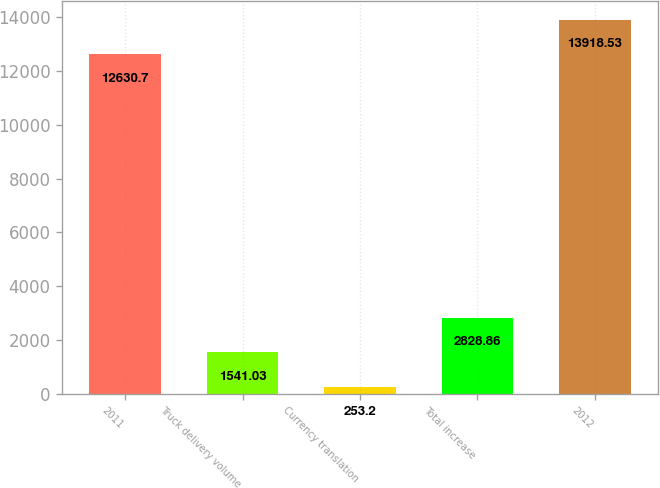Convert chart. <chart><loc_0><loc_0><loc_500><loc_500><bar_chart><fcel>2011<fcel>Truck delivery volume<fcel>Currency translation<fcel>Total increase<fcel>2012<nl><fcel>12630.7<fcel>1541.03<fcel>253.2<fcel>2828.86<fcel>13918.5<nl></chart> 